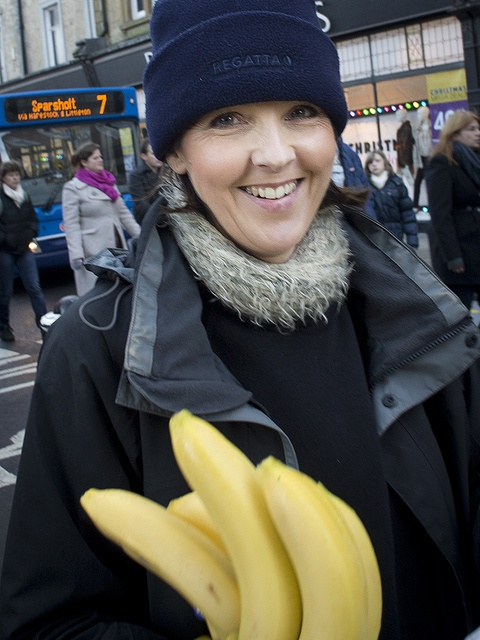Describe the objects in this image and their specific colors. I can see people in black, lightgray, gray, and tan tones, banana in lightgray, tan, and khaki tones, bus in lightgray, black, purple, navy, and blue tones, people in lightgray, darkgray, and gray tones, and people in lightgray, black, gray, navy, and darkgray tones in this image. 